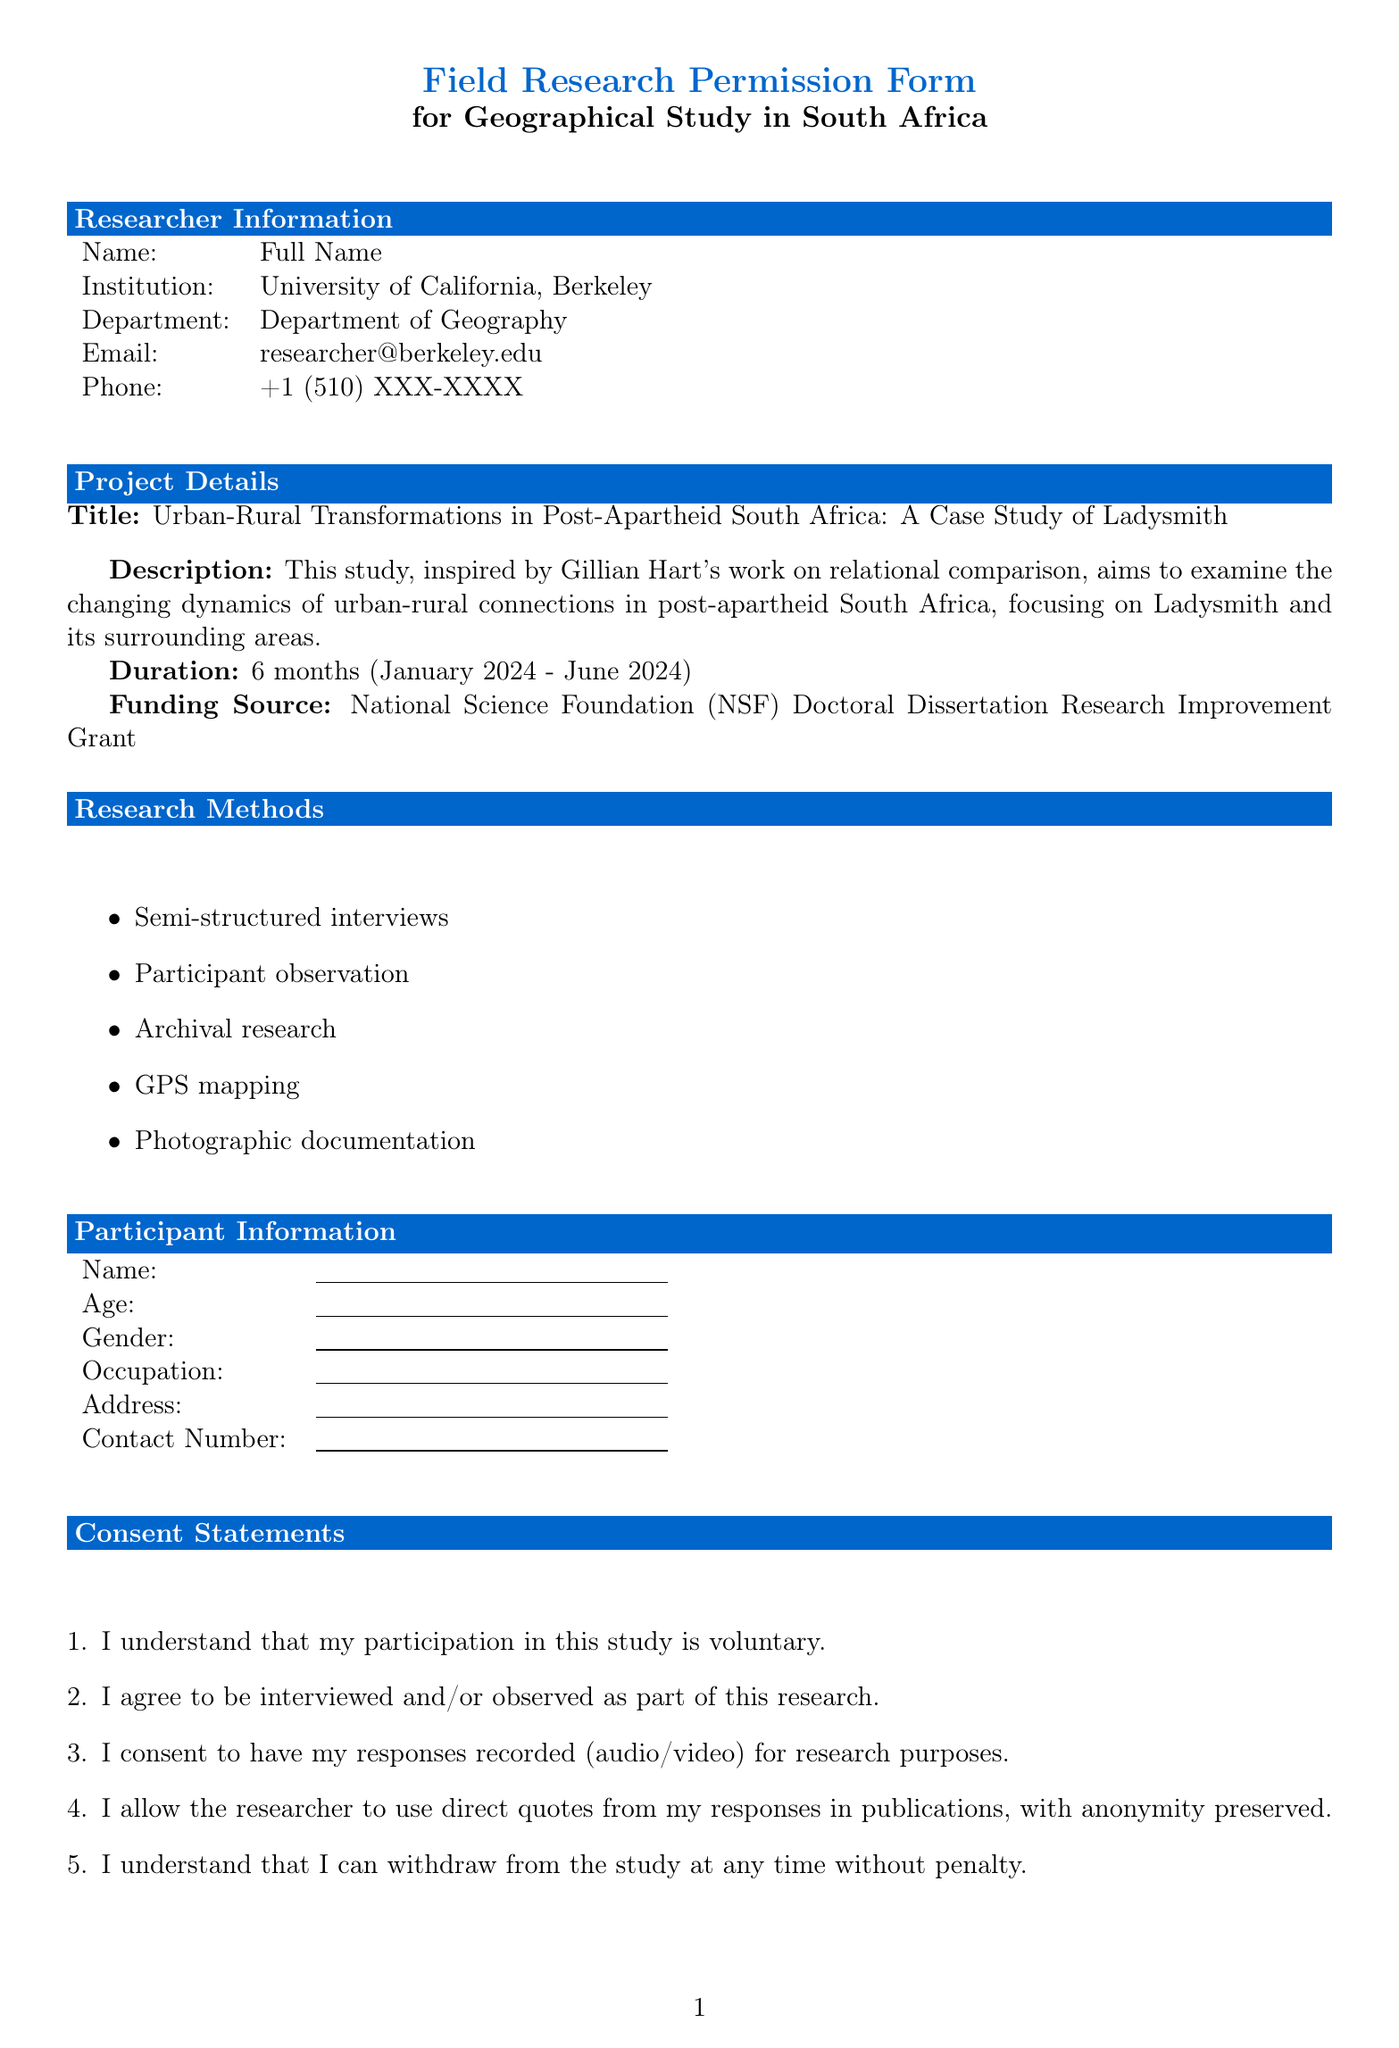What is the title of the research project? The title of the research project is explicitly mentioned in the document under "Project Details."
Answer: Urban-Rural Transformations in Post-Apartheid South Africa: A Case Study of Ladysmith Who is the primary researcher affiliated with? The primary researcher is affiliated with the University of California, Berkeley, as stated in the "Researcher Information" section.
Answer: University of California, Berkeley What is the duration of the study? The duration of the study is specified in the "Project Details" section as 6 months.
Answer: 6 months What methods will be used in the research? The research methods are listed in the "Research Methods" section, denoting different approaches employed in the study.
Answer: Semi-structured interviews, Participant observation, Archival research, GPS mapping, Photographic documentation Which Ethical Review Board has approved this research? The Ethical Review Board responsible for the study can be found in the "Ethical Considerations" section, where it is specified.
Answer: University of California, Berkeley Institutional Review Board What is the contact information for the emergency contact? The emergency contact's information, including their name, role, email, and phone number, is detailed in the document under "Emergency Contact."
Answer: Dr. Gillian Hart, Research Supervisor, hart@berkeley.edu, +1 (510) XXX-XXXX How long will data be retained after the study? The retention period for data after the study is mentioned in the "Data Protection" section.
Answer: 5 years post-study completion What type of research is this study associated with? This question pertains to the nature of the study, which is implied in its description.
Answer: Geographical Study What kind of consent is required from participants? The consent statements provided in the "Consent Statements" section specify participant agreements needed for the study.
Answer: I understand that my participation in this study is voluntary 